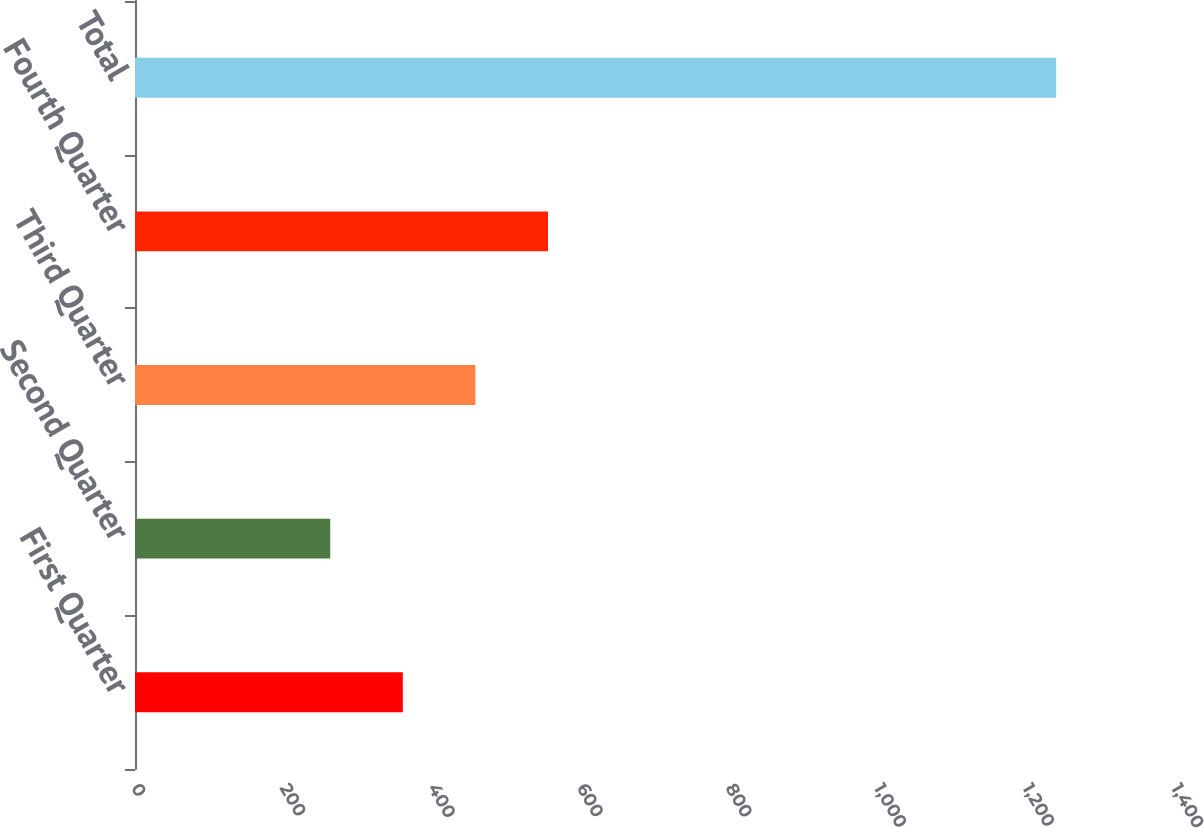Convert chart. <chart><loc_0><loc_0><loc_500><loc_500><bar_chart><fcel>First Quarter<fcel>Second Quarter<fcel>Third Quarter<fcel>Fourth Quarter<fcel>Total<nl><fcel>360.52<fcel>262.8<fcel>458.24<fcel>555.96<fcel>1240<nl></chart> 